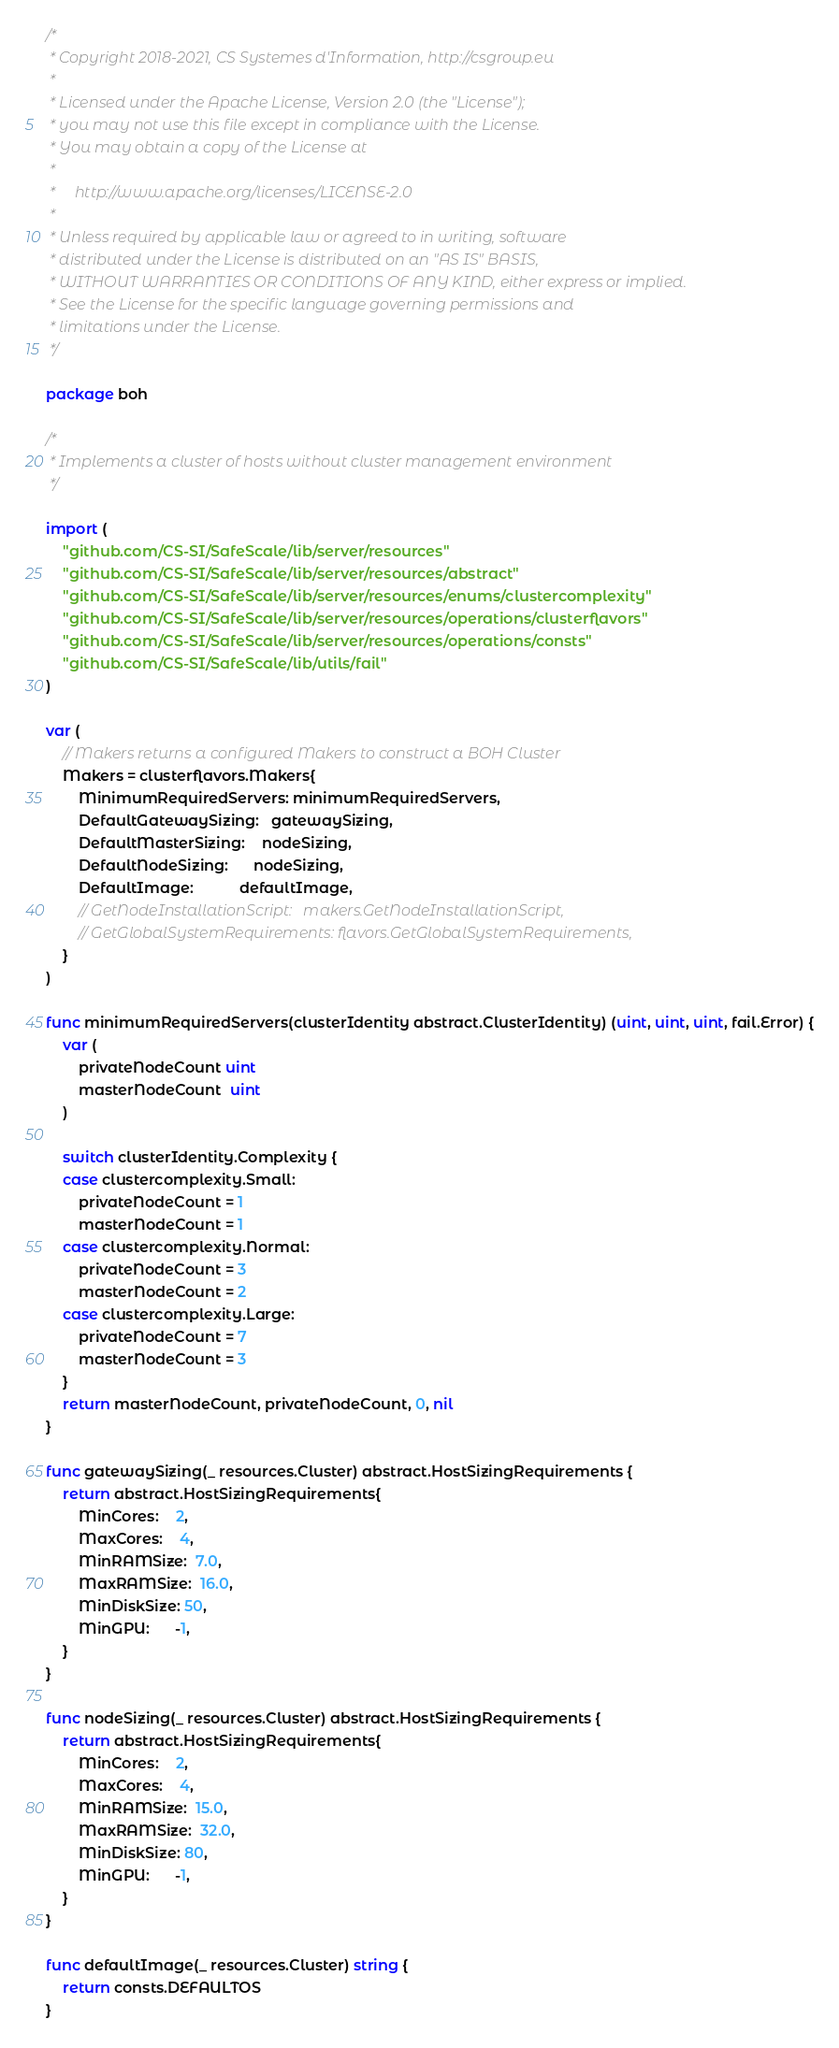Convert code to text. <code><loc_0><loc_0><loc_500><loc_500><_Go_>/*
 * Copyright 2018-2021, CS Systemes d'Information, http://csgroup.eu
 *
 * Licensed under the Apache License, Version 2.0 (the "License");
 * you may not use this file except in compliance with the License.
 * You may obtain a copy of the License at
 *
 *     http://www.apache.org/licenses/LICENSE-2.0
 *
 * Unless required by applicable law or agreed to in writing, software
 * distributed under the License is distributed on an "AS IS" BASIS,
 * WITHOUT WARRANTIES OR CONDITIONS OF ANY KIND, either express or implied.
 * See the License for the specific language governing permissions and
 * limitations under the License.
 */

package boh

/*
 * Implements a cluster of hosts without cluster management environment
 */

import (
	"github.com/CS-SI/SafeScale/lib/server/resources"
	"github.com/CS-SI/SafeScale/lib/server/resources/abstract"
	"github.com/CS-SI/SafeScale/lib/server/resources/enums/clustercomplexity"
	"github.com/CS-SI/SafeScale/lib/server/resources/operations/clusterflavors"
	"github.com/CS-SI/SafeScale/lib/server/resources/operations/consts"
	"github.com/CS-SI/SafeScale/lib/utils/fail"
)

var (
	// Makers returns a configured Makers to construct a BOH Cluster
	Makers = clusterflavors.Makers{
		MinimumRequiredServers: minimumRequiredServers,
		DefaultGatewaySizing:   gatewaySizing,
		DefaultMasterSizing:    nodeSizing,
		DefaultNodeSizing:      nodeSizing,
		DefaultImage:           defaultImage,
		// GetNodeInstallationScript:   makers.GetNodeInstallationScript,
		// GetGlobalSystemRequirements: flavors.GetGlobalSystemRequirements,
	}
)

func minimumRequiredServers(clusterIdentity abstract.ClusterIdentity) (uint, uint, uint, fail.Error) {
	var (
		privateNodeCount uint
		masterNodeCount  uint
	)

	switch clusterIdentity.Complexity {
	case clustercomplexity.Small:
		privateNodeCount = 1
		masterNodeCount = 1
	case clustercomplexity.Normal:
		privateNodeCount = 3
		masterNodeCount = 2
	case clustercomplexity.Large:
		privateNodeCount = 7
		masterNodeCount = 3
	}
	return masterNodeCount, privateNodeCount, 0, nil
}

func gatewaySizing(_ resources.Cluster) abstract.HostSizingRequirements {
	return abstract.HostSizingRequirements{
		MinCores:    2,
		MaxCores:    4,
		MinRAMSize:  7.0,
		MaxRAMSize:  16.0,
		MinDiskSize: 50,
		MinGPU:      -1,
	}
}

func nodeSizing(_ resources.Cluster) abstract.HostSizingRequirements {
	return abstract.HostSizingRequirements{
		MinCores:    2,
		MaxCores:    4,
		MinRAMSize:  15.0,
		MaxRAMSize:  32.0,
		MinDiskSize: 80,
		MinGPU:      -1,
	}
}

func defaultImage(_ resources.Cluster) string {
	return consts.DEFAULTOS
}
</code> 